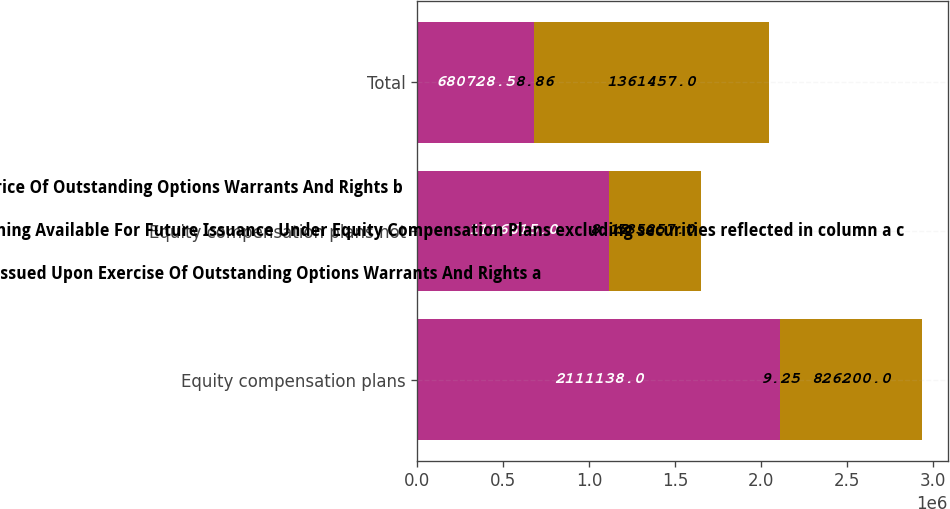Convert chart. <chart><loc_0><loc_0><loc_500><loc_500><stacked_bar_chart><ecel><fcel>Equity compensation plans<fcel>Equity compensation plans not<fcel>Total<nl><fcel>WeightedAverage Exercise Price Of Outstanding Options Warrants And Rights b<fcel>2.11114e+06<fcel>1.11662e+06<fcel>680728<nl><fcel>Number Of Securities Remaining Available For Future Issuance Under Equity Compensation Plans excluding securities reflected in column a c<fcel>9.25<fcel>8.12<fcel>8.86<nl><fcel>Number Of Securities To Be Issued Upon Exercise Of Outstanding Options Warrants And Rights a<fcel>826200<fcel>535257<fcel>1.36146e+06<nl></chart> 